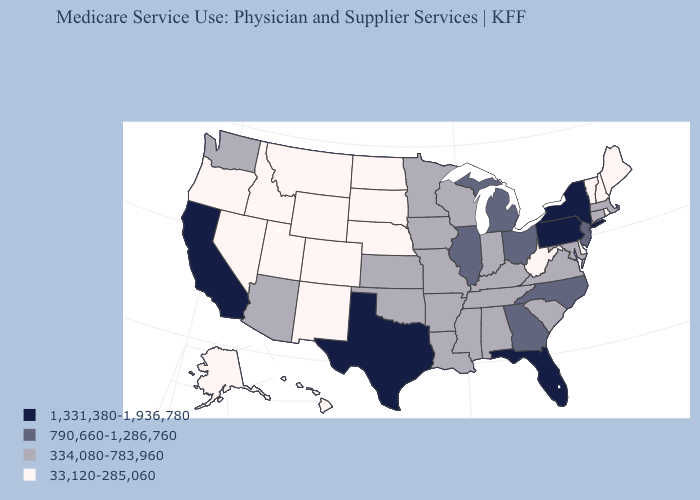Does Hawaii have a lower value than North Carolina?
Be succinct. Yes. Among the states that border South Dakota , which have the lowest value?
Answer briefly. Montana, Nebraska, North Dakota, Wyoming. Among the states that border Maryland , does Delaware have the highest value?
Give a very brief answer. No. What is the value of Michigan?
Answer briefly. 790,660-1,286,760. What is the value of Louisiana?
Short answer required. 334,080-783,960. How many symbols are there in the legend?
Keep it brief. 4. What is the lowest value in states that border New Mexico?
Quick response, please. 33,120-285,060. What is the value of Rhode Island?
Quick response, please. 33,120-285,060. What is the lowest value in states that border Wisconsin?
Write a very short answer. 334,080-783,960. Name the states that have a value in the range 33,120-285,060?
Be succinct. Alaska, Colorado, Delaware, Hawaii, Idaho, Maine, Montana, Nebraska, Nevada, New Hampshire, New Mexico, North Dakota, Oregon, Rhode Island, South Dakota, Utah, Vermont, West Virginia, Wyoming. Name the states that have a value in the range 790,660-1,286,760?
Short answer required. Georgia, Illinois, Michigan, New Jersey, North Carolina, Ohio. What is the value of Colorado?
Give a very brief answer. 33,120-285,060. Which states have the lowest value in the MidWest?
Give a very brief answer. Nebraska, North Dakota, South Dakota. Name the states that have a value in the range 334,080-783,960?
Quick response, please. Alabama, Arizona, Arkansas, Connecticut, Indiana, Iowa, Kansas, Kentucky, Louisiana, Maryland, Massachusetts, Minnesota, Mississippi, Missouri, Oklahoma, South Carolina, Tennessee, Virginia, Washington, Wisconsin. How many symbols are there in the legend?
Be succinct. 4. 